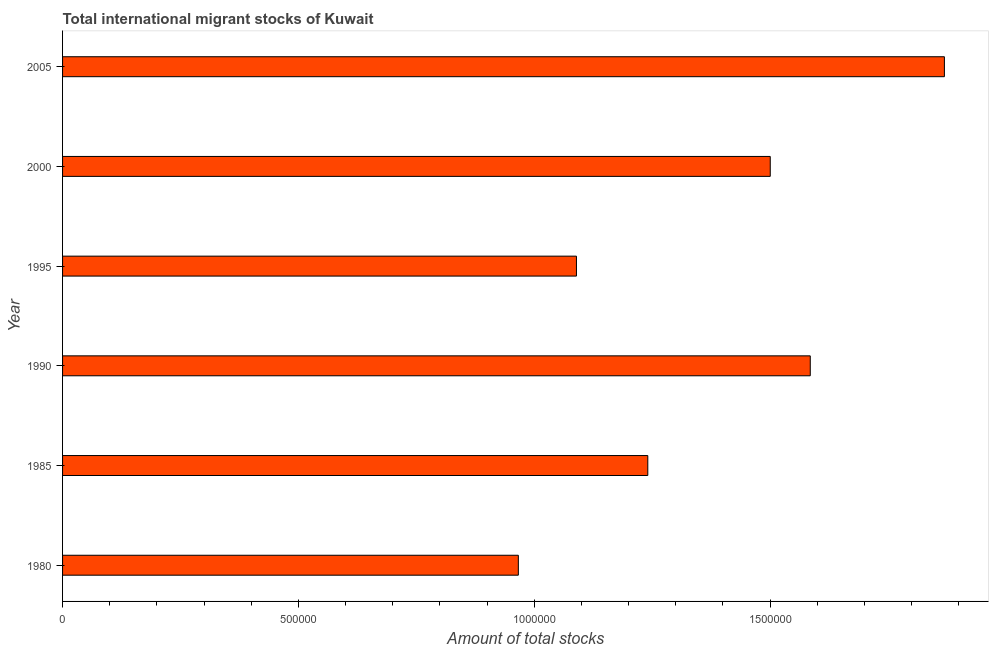Does the graph contain grids?
Keep it short and to the point. No. What is the title of the graph?
Offer a terse response. Total international migrant stocks of Kuwait. What is the label or title of the X-axis?
Ensure brevity in your answer.  Amount of total stocks. What is the label or title of the Y-axis?
Your response must be concise. Year. What is the total number of international migrant stock in 1995?
Give a very brief answer. 1.09e+06. Across all years, what is the maximum total number of international migrant stock?
Give a very brief answer. 1.87e+06. Across all years, what is the minimum total number of international migrant stock?
Your response must be concise. 9.66e+05. In which year was the total number of international migrant stock maximum?
Offer a terse response. 2005. What is the sum of the total number of international migrant stock?
Your answer should be very brief. 8.25e+06. What is the difference between the total number of international migrant stock in 1980 and 1990?
Your response must be concise. -6.19e+05. What is the average total number of international migrant stock per year?
Offer a terse response. 1.38e+06. What is the median total number of international migrant stock?
Your response must be concise. 1.37e+06. In how many years, is the total number of international migrant stock greater than 400000 ?
Provide a short and direct response. 6. Do a majority of the years between 2000 and 2005 (inclusive) have total number of international migrant stock greater than 900000 ?
Give a very brief answer. Yes. What is the ratio of the total number of international migrant stock in 2000 to that in 2005?
Keep it short and to the point. 0.8. Is the total number of international migrant stock in 1985 less than that in 2005?
Your response must be concise. Yes. What is the difference between the highest and the second highest total number of international migrant stock?
Offer a terse response. 2.84e+05. Is the sum of the total number of international migrant stock in 1995 and 2000 greater than the maximum total number of international migrant stock across all years?
Offer a very short reply. Yes. What is the difference between the highest and the lowest total number of international migrant stock?
Offer a very short reply. 9.03e+05. In how many years, is the total number of international migrant stock greater than the average total number of international migrant stock taken over all years?
Your response must be concise. 3. How many bars are there?
Provide a succinct answer. 6. Are the values on the major ticks of X-axis written in scientific E-notation?
Offer a very short reply. No. What is the Amount of total stocks in 1980?
Offer a very short reply. 9.66e+05. What is the Amount of total stocks in 1985?
Keep it short and to the point. 1.24e+06. What is the Amount of total stocks in 1990?
Ensure brevity in your answer.  1.59e+06. What is the Amount of total stocks of 1995?
Your answer should be compact. 1.09e+06. What is the Amount of total stocks of 2000?
Give a very brief answer. 1.50e+06. What is the Amount of total stocks of 2005?
Give a very brief answer. 1.87e+06. What is the difference between the Amount of total stocks in 1980 and 1985?
Your response must be concise. -2.74e+05. What is the difference between the Amount of total stocks in 1980 and 1990?
Your answer should be compact. -6.19e+05. What is the difference between the Amount of total stocks in 1980 and 1995?
Give a very brief answer. -1.23e+05. What is the difference between the Amount of total stocks in 1980 and 2000?
Your answer should be compact. -5.34e+05. What is the difference between the Amount of total stocks in 1980 and 2005?
Keep it short and to the point. -9.03e+05. What is the difference between the Amount of total stocks in 1985 and 1990?
Make the answer very short. -3.44e+05. What is the difference between the Amount of total stocks in 1985 and 1995?
Your response must be concise. 1.51e+05. What is the difference between the Amount of total stocks in 1985 and 2000?
Offer a very short reply. -2.60e+05. What is the difference between the Amount of total stocks in 1985 and 2005?
Give a very brief answer. -6.29e+05. What is the difference between the Amount of total stocks in 1990 and 1995?
Offer a terse response. 4.96e+05. What is the difference between the Amount of total stocks in 1990 and 2000?
Offer a very short reply. 8.48e+04. What is the difference between the Amount of total stocks in 1990 and 2005?
Your answer should be very brief. -2.84e+05. What is the difference between the Amount of total stocks in 1995 and 2000?
Make the answer very short. -4.11e+05. What is the difference between the Amount of total stocks in 1995 and 2005?
Your answer should be compact. -7.80e+05. What is the difference between the Amount of total stocks in 2000 and 2005?
Ensure brevity in your answer.  -3.69e+05. What is the ratio of the Amount of total stocks in 1980 to that in 1985?
Ensure brevity in your answer.  0.78. What is the ratio of the Amount of total stocks in 1980 to that in 1990?
Offer a very short reply. 0.61. What is the ratio of the Amount of total stocks in 1980 to that in 1995?
Give a very brief answer. 0.89. What is the ratio of the Amount of total stocks in 1980 to that in 2000?
Provide a short and direct response. 0.64. What is the ratio of the Amount of total stocks in 1980 to that in 2005?
Offer a very short reply. 0.52. What is the ratio of the Amount of total stocks in 1985 to that in 1990?
Offer a very short reply. 0.78. What is the ratio of the Amount of total stocks in 1985 to that in 1995?
Provide a succinct answer. 1.14. What is the ratio of the Amount of total stocks in 1985 to that in 2000?
Ensure brevity in your answer.  0.83. What is the ratio of the Amount of total stocks in 1985 to that in 2005?
Make the answer very short. 0.66. What is the ratio of the Amount of total stocks in 1990 to that in 1995?
Your answer should be very brief. 1.46. What is the ratio of the Amount of total stocks in 1990 to that in 2000?
Give a very brief answer. 1.06. What is the ratio of the Amount of total stocks in 1990 to that in 2005?
Keep it short and to the point. 0.85. What is the ratio of the Amount of total stocks in 1995 to that in 2000?
Ensure brevity in your answer.  0.73. What is the ratio of the Amount of total stocks in 1995 to that in 2005?
Give a very brief answer. 0.58. What is the ratio of the Amount of total stocks in 2000 to that in 2005?
Offer a terse response. 0.8. 